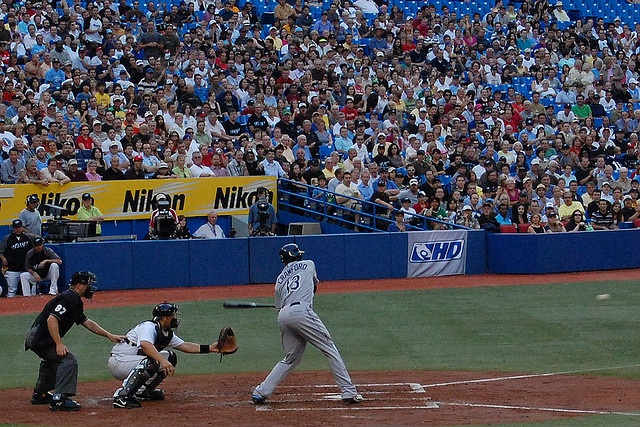Describe the objects in this image and their specific colors. I can see people in gray, black, navy, and darkgray tones, people in gray, black, darkgray, and maroon tones, people in gray, darkgray, and black tones, people in gray, black, brown, and navy tones, and people in gray, black, and navy tones in this image. 